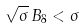Convert formula to latex. <formula><loc_0><loc_0><loc_500><loc_500>\sqrt { \sigma } \, B _ { 8 } < \sigma</formula> 